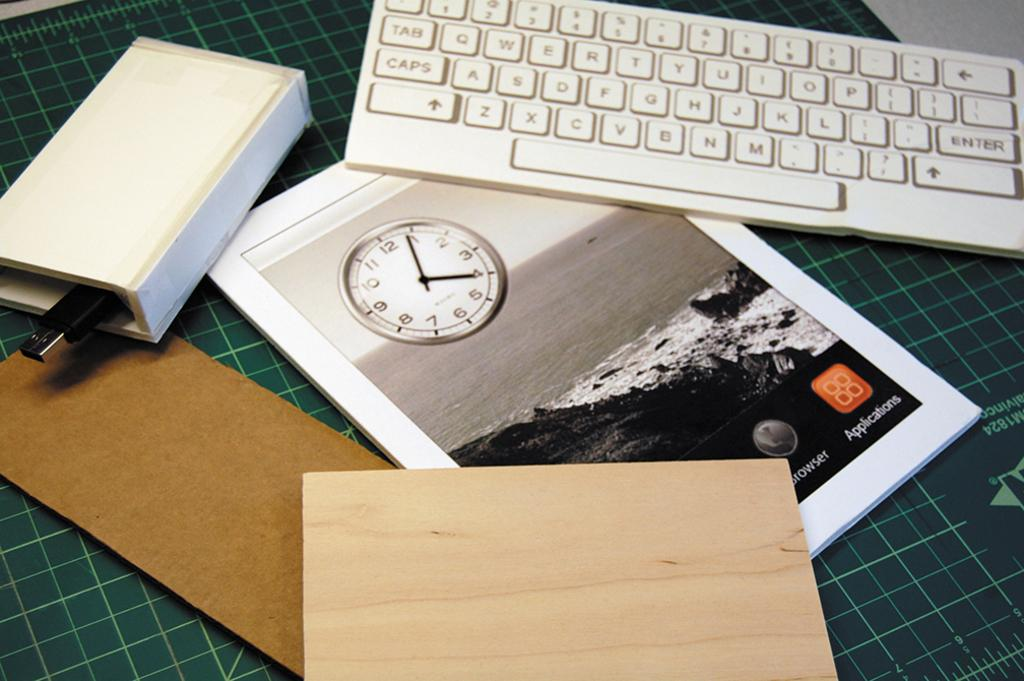<image>
Offer a succinct explanation of the picture presented. A keyboard and a book about applications on a table. 